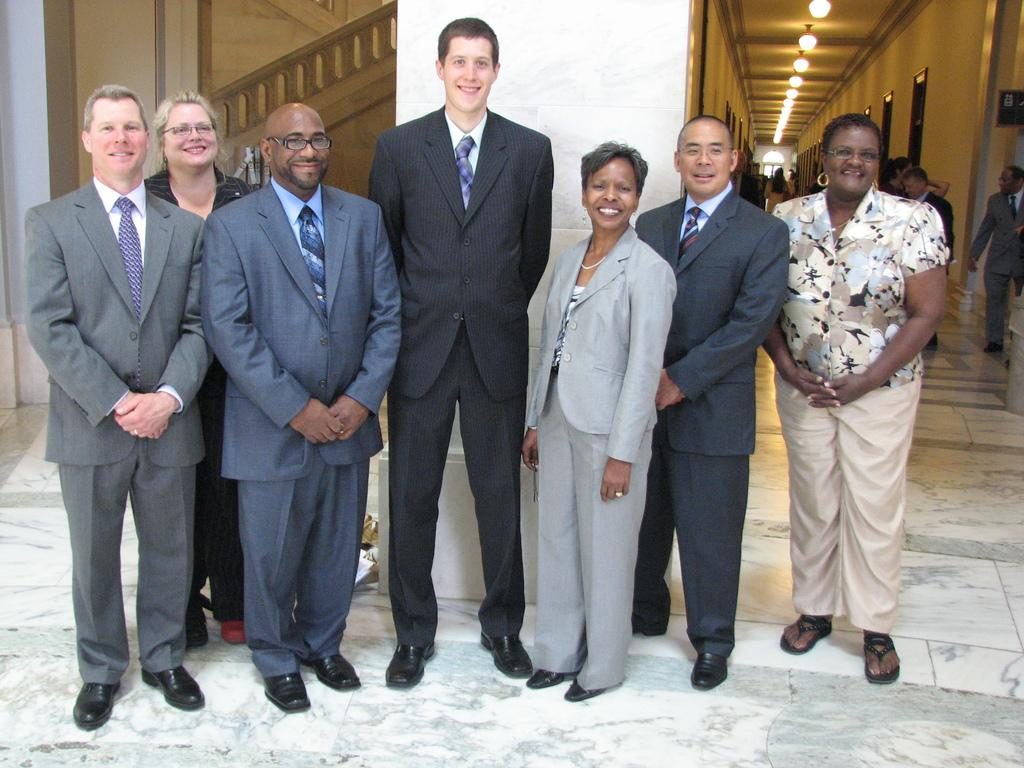What are the people in the image doing? The persons standing on the floor are smiling. What can be seen in the background of the image? There is a wall, lights, doors, and a roof in the background. What type of metal can be seen on the market stalls in the image? There is no market or metal present in the image; it features persons standing on the floor and a background with a wall, lights, doors, and a roof. How many snails are visible on the persons in the image? There are no snails present in the image; the persons are smiling and standing on the floor. 